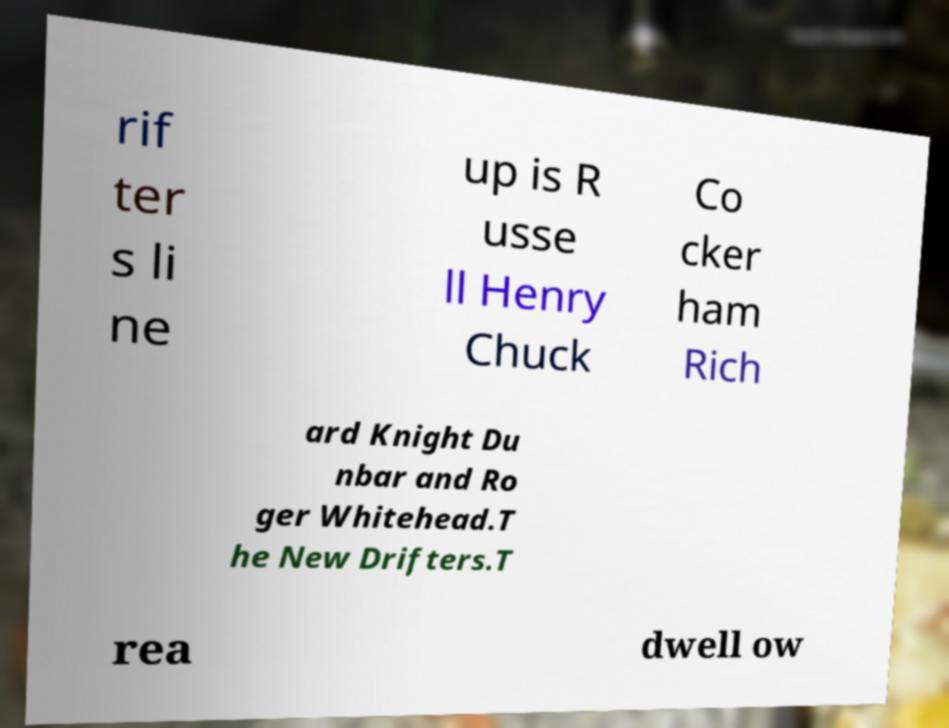Could you extract and type out the text from this image? rif ter s li ne up is R usse ll Henry Chuck Co cker ham Rich ard Knight Du nbar and Ro ger Whitehead.T he New Drifters.T rea dwell ow 